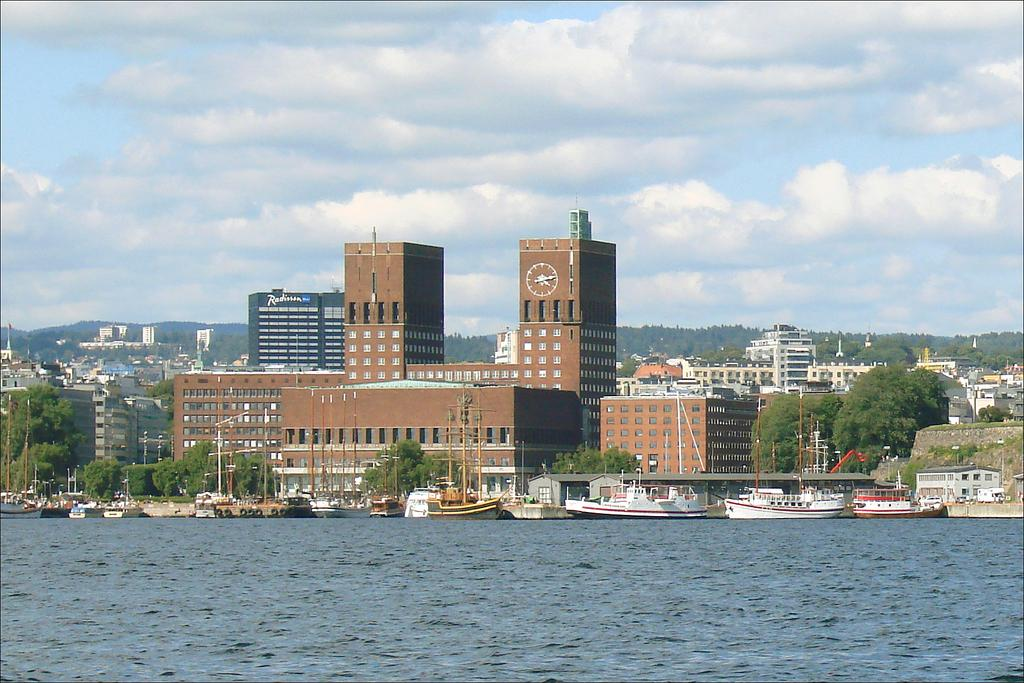What can be seen in the background of the image? There are buildings, trees, and poles in the background of the image. What is visible at the top of the image? The sky is visible at the top of the image. What is present in the sky? Clouds are present in the sky. What can be seen at the bottom of the image? There is water visible at the bottom of the image. What is in the water? There are boats in the water. What caption is written on the boats in the image? There is no caption written on the boats in the image. Can you hear the boats cry in the image? Boats do not have the ability to cry, and there is no sound in the image. 